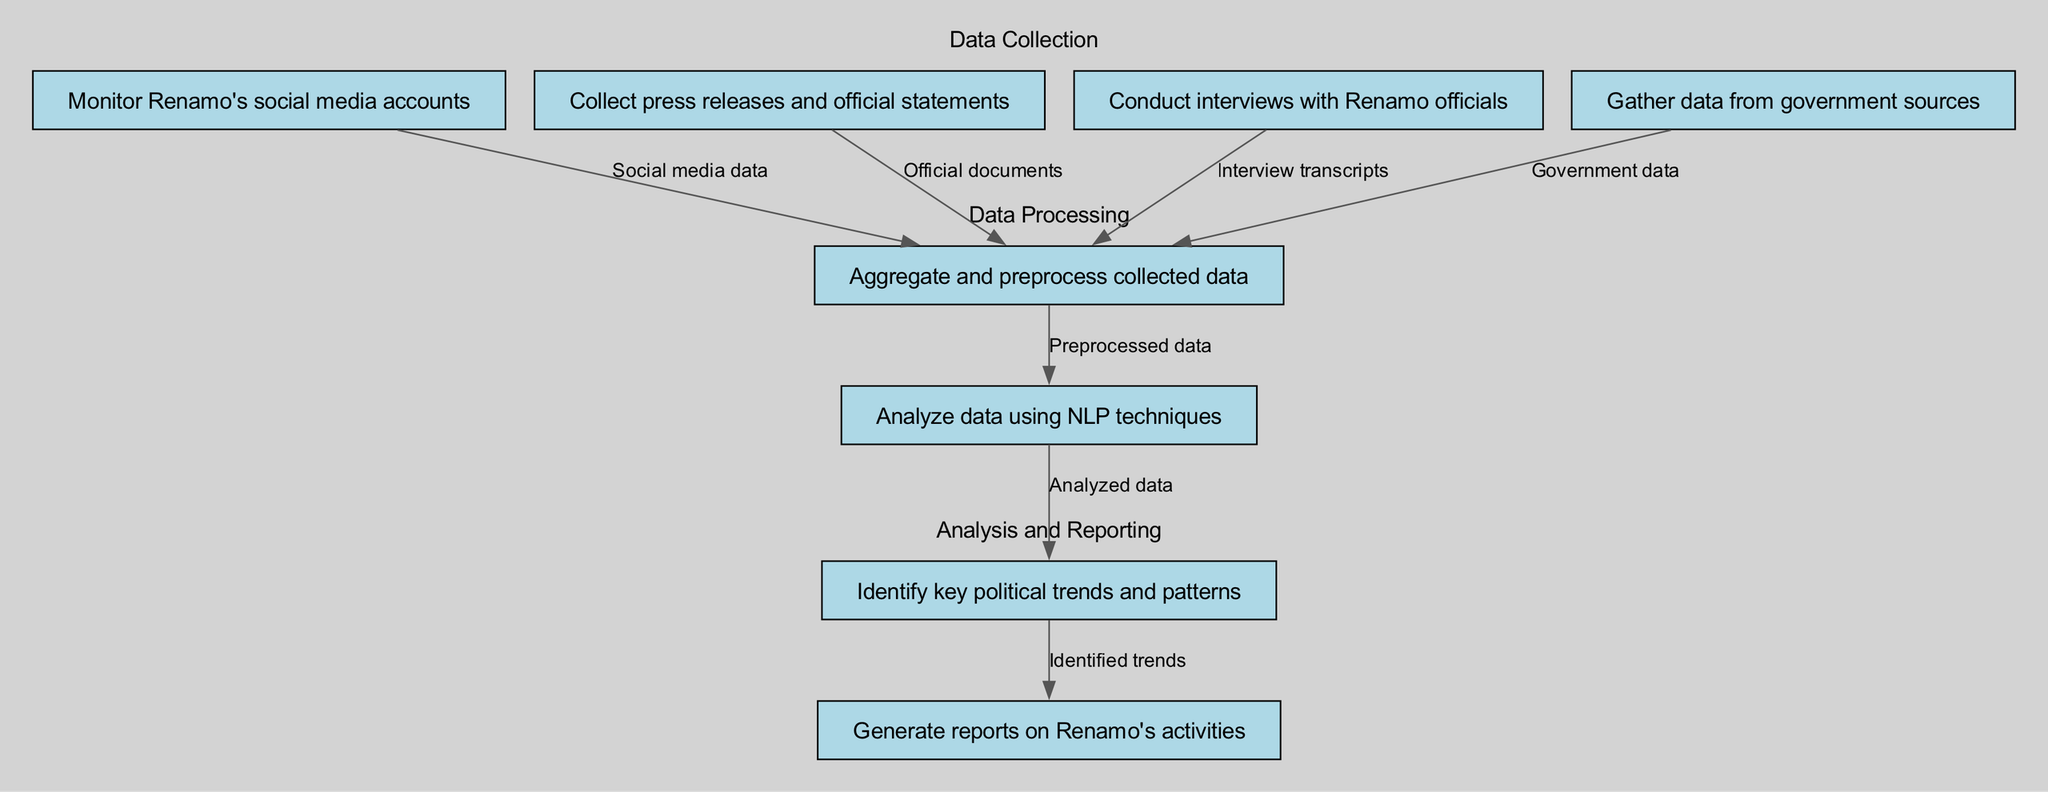What is the first step in the data collection process? The diagram indicates that the first step is to monitor Renamo's social media accounts, as this is the initial node listed in the "Data Collection" section.
Answer: Monitor Renamo's social media accounts How many nodes are there in total? By counting each distinct process or action depicted in the diagram, we see there are eight nodes that represent each step in the process.
Answer: 8 What type of data is collected from interviews? The diagram specifies that interviews with Renamo officials yield interview transcripts, which categorizes the type of data collected from that step.
Answer: Interview transcripts Which step comes after data aggregation and preprocessing? The diagram shows that after aggregating and preprocessing the collected data, the next step is analyzing data using NLP techniques. This establishes a direct sequence from one step to another in the process.
Answer: Analyze data using NLP techniques What is the outcome of the analysis stage? The outcome of the analysis stage is the identification of key political trends and patterns, as indicated in the diagram which links the analysis node to the trends and patterns node.
Answer: Identify key political trends and patterns How many types of data collection methods are depicted? The diagram lists four distinct methods for data collection: monitoring social media, collecting press releases, conducting interviews, and gathering government data. Thus, there are four types of methods shown.
Answer: 4 What connects the data aggregation step to the analysis step? The connection from the data aggregation step to the analysis step is facilitated by the transition to the preprocessed data, as depicted in the diagram. This indicates that the data must be preprocessed before analysis can occur.
Answer: Preprocessed data Which two nodes represent the final steps in the diagram? The final steps in the diagram are the identification of trends and patterns and the generation of reports on Renamo's activities. These two nodes summarize the conclusion of the overall process depicted in the diagram.
Answer: Generate reports on Renamo's activities What is the last action performed in the process? The last action performed in the process is to generate reports on Renamo's activities, marking the conclusion of the data collection and analysis workflow depicted in the diagram.
Answer: Generate reports on Renamo's activities 